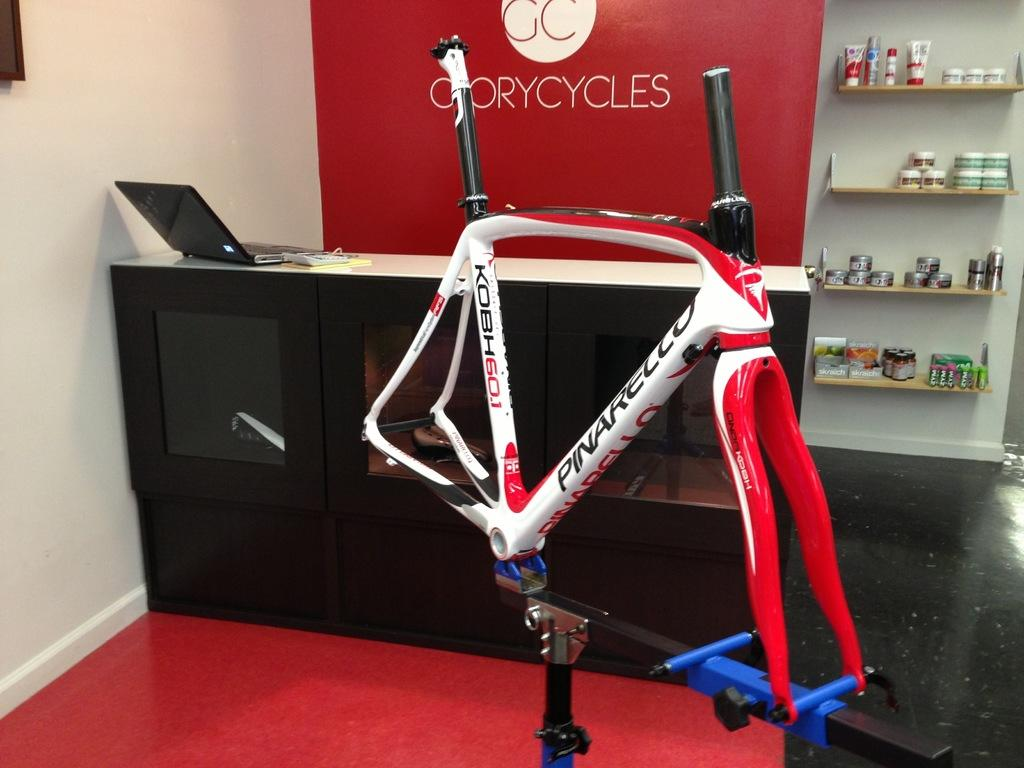<image>
Render a clear and concise summary of the photo. a store called Glorycycles has a bike on display is the froNT 